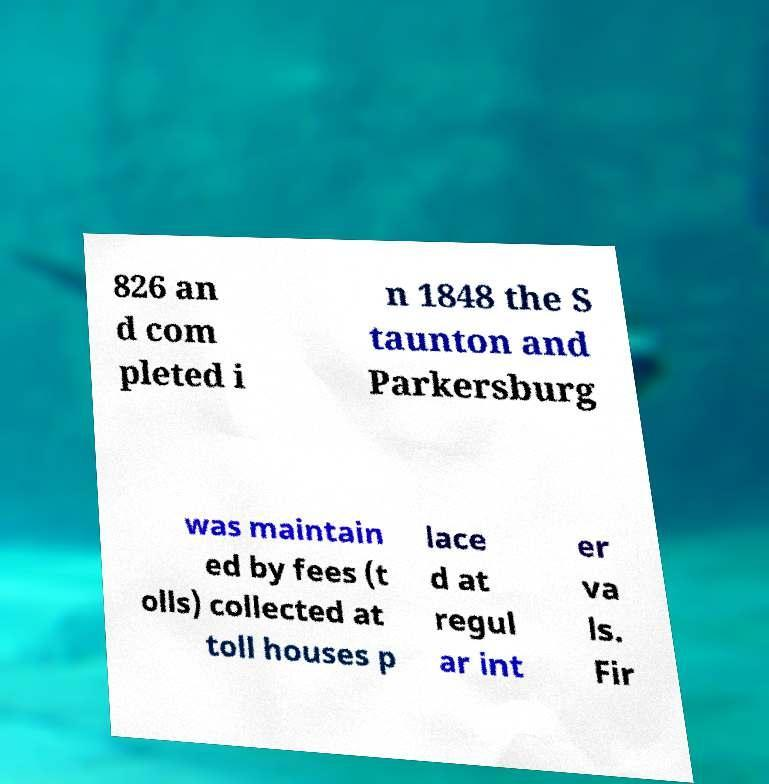Please identify and transcribe the text found in this image. 826 an d com pleted i n 1848 the S taunton and Parkersburg was maintain ed by fees (t olls) collected at toll houses p lace d at regul ar int er va ls. Fir 